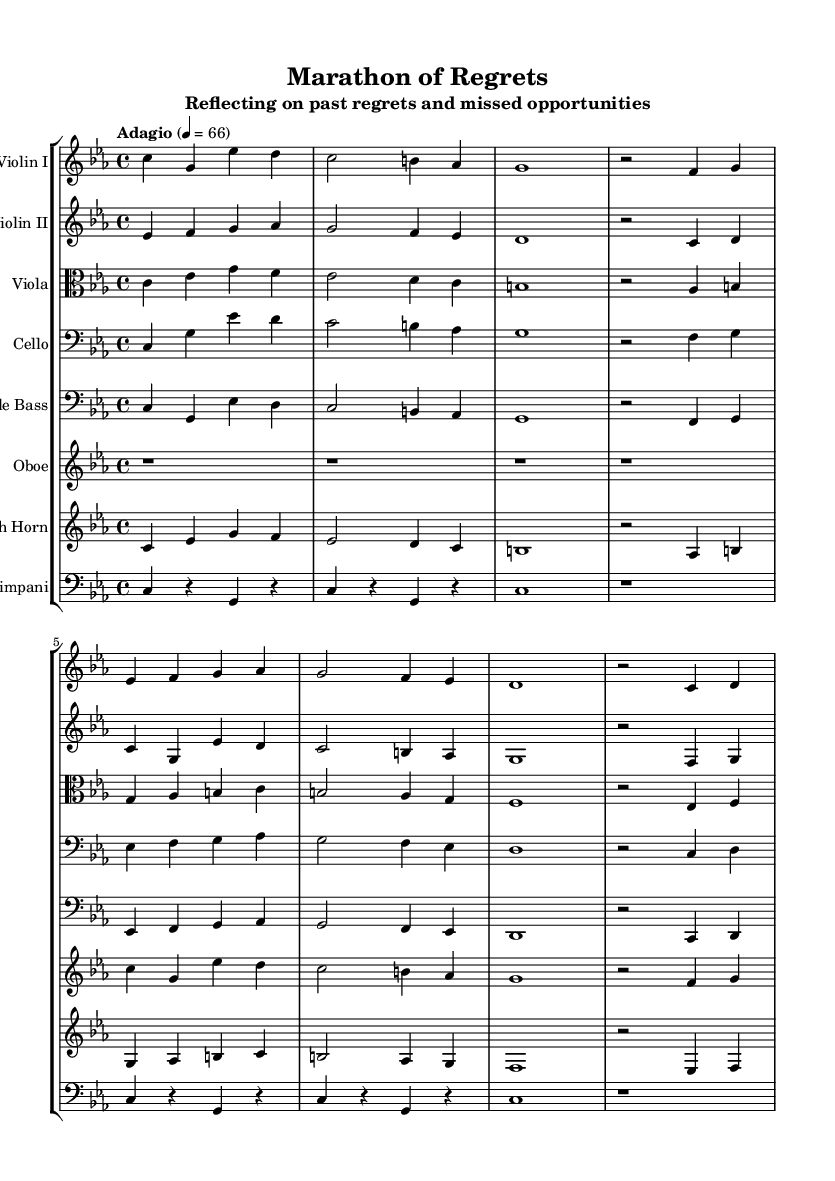What is the key signature of this music? The key signature is indicated by the key at the beginning of the staff. In this piece, it is stated as C minor, which has three flats (B flat, E flat, A flat).
Answer: C minor What is the time signature of this music? The time signature can be found at the start of the piece, presented as a fraction. Here, it is shown as 4/4, meaning there are four beats in a measure, and a quarter note receives one beat.
Answer: 4/4 What is the tempo marking of this music? The tempo is indicated in the header with the Italian term "Adagio," along with a metronome marking of 66, meaning the piece should be played slowly at 66 beats per minute.
Answer: Adagio Which instruments are present in this symphony? The instruments are listed in the score header and throughout the score in their respective staffs. Here, the instruments included are Violin I, Violin II, Viola, Cello, Double Bass, Oboe, French Horn, and Timpani.
Answer: Violin I, Violin II, Viola, Cello, Double Bass, Oboe, French Horn, Timpani What is the rhythmic texture of the opening measures? To determine the rhythmic texture, one can analyze the rhythmic values of the notes in the opening measures of the score. The opening measures contain mostly quarter notes and a few half notes, which contributes to a flowing yet sparse texture characteristic of a melancholic piece.
Answer: Sparse How many measures are present in the first section? To find the number of measures, you can count each measure line by line. The first section of the score contains a total of 8 measures before a repeat occurs in different instruments, indicating a total of 8 distinct measures before any variation.
Answer: 8 